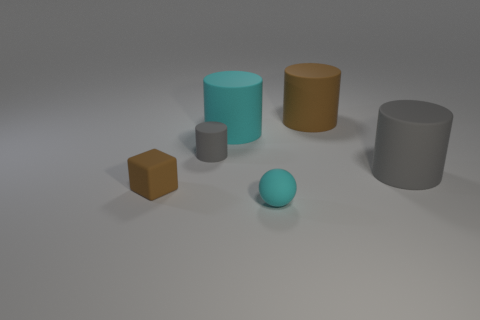There is a cylinder that is to the left of the cyan object behind the small ball; what color is it?
Your response must be concise. Gray. There is a cylinder that is the same size as the block; what color is it?
Offer a very short reply. Gray. What number of small things are either gray matte objects or cyan rubber cubes?
Give a very brief answer. 1. Are there more brown objects behind the brown rubber cylinder than large matte things that are left of the small rubber cube?
Your response must be concise. No. There is a thing that is the same color as the ball; what is its size?
Provide a succinct answer. Large. What number of other things are there of the same size as the cyan matte cylinder?
Give a very brief answer. 2. Are the tiny object that is in front of the tiny brown matte thing and the big cyan thing made of the same material?
Provide a succinct answer. Yes. How many other objects are there of the same color as the small matte block?
Make the answer very short. 1. How many other objects are the same shape as the large gray rubber thing?
Provide a succinct answer. 3. There is a gray thing that is left of the big gray cylinder; is it the same shape as the brown matte object that is in front of the big brown rubber cylinder?
Provide a succinct answer. No. 